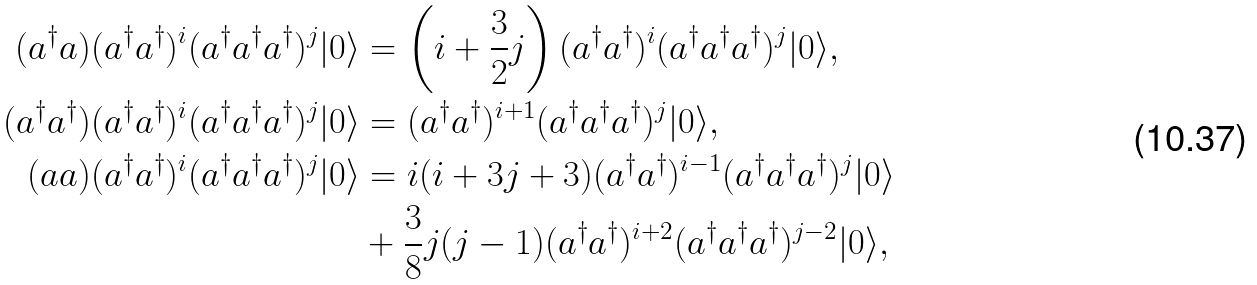<formula> <loc_0><loc_0><loc_500><loc_500>( a ^ { \dagger } a ) ( a ^ { \dagger } a ^ { \dagger } ) ^ { i } ( a ^ { \dagger } a ^ { \dagger } a ^ { \dagger } ) ^ { j } | 0 \rangle & = \left ( i + \frac { 3 } { 2 } j \right ) ( a ^ { \dagger } a ^ { \dagger } ) ^ { i } ( a ^ { \dagger } a ^ { \dagger } a ^ { \dagger } ) ^ { j } | 0 \rangle , \\ ( a ^ { \dagger } a ^ { \dagger } ) ( a ^ { \dagger } a ^ { \dagger } ) ^ { i } ( a ^ { \dagger } a ^ { \dagger } a ^ { \dagger } ) ^ { j } | 0 \rangle & = ( a ^ { \dagger } a ^ { \dagger } ) ^ { i + 1 } ( a ^ { \dagger } a ^ { \dagger } a ^ { \dagger } ) ^ { j } | 0 \rangle , \\ ( a a ) ( a ^ { \dagger } a ^ { \dagger } ) ^ { i } ( a ^ { \dagger } a ^ { \dagger } a ^ { \dagger } ) ^ { j } | 0 \rangle & = i ( i + 3 j + 3 ) ( a ^ { \dagger } a ^ { \dagger } ) ^ { i - 1 } ( a ^ { \dagger } a ^ { \dagger } a ^ { \dagger } ) ^ { j } | 0 \rangle \\ & + \frac { 3 } { 8 } j ( j - 1 ) ( a ^ { \dagger } a ^ { \dagger } ) ^ { i + 2 } ( a ^ { \dagger } a ^ { \dagger } a ^ { \dagger } ) ^ { j - 2 } | 0 \rangle ,</formula> 